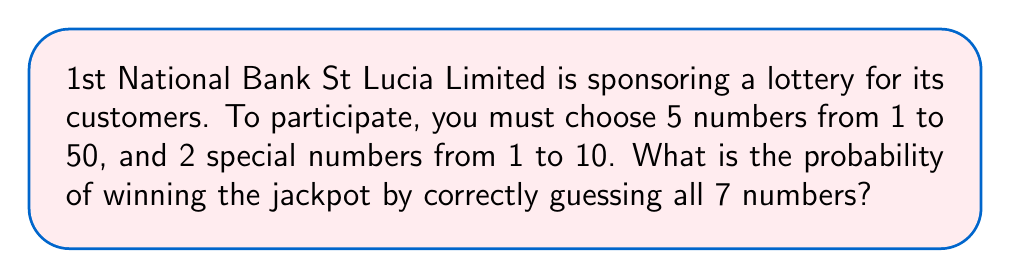Solve this math problem. To solve this problem, we need to calculate the total number of possible combinations and then determine the probability of choosing the correct combination.

1. First, let's calculate the number of ways to choose 5 numbers from 50:
   This is a combination problem, denoted as $\binom{50}{5}$
   $$\binom{50}{5} = \frac{50!}{5!(50-5)!} = \frac{50!}{5!45!} = 2,118,760$$

2. Next, we calculate the number of ways to choose 2 numbers from 10:
   $$\binom{10}{2} = \frac{10!}{2!(10-2)!} = \frac{10!}{2!8!} = 45$$

3. The total number of possible combinations is the product of these two results:
   $$2,118,760 \times 45 = 95,344,200$$

4. The probability of winning is choosing the correct combination out of all possible combinations:
   $$P(\text{winning}) = \frac{1}{95,344,200}$$

This can be simplified to:
   $$P(\text{winning}) = \frac{1}{95,344,200} \approx 1.049 \times 10^{-8}$$
Answer: The probability of winning the jackpot is $\frac{1}{95,344,200}$ or approximately $1.049 \times 10^{-8}$. 